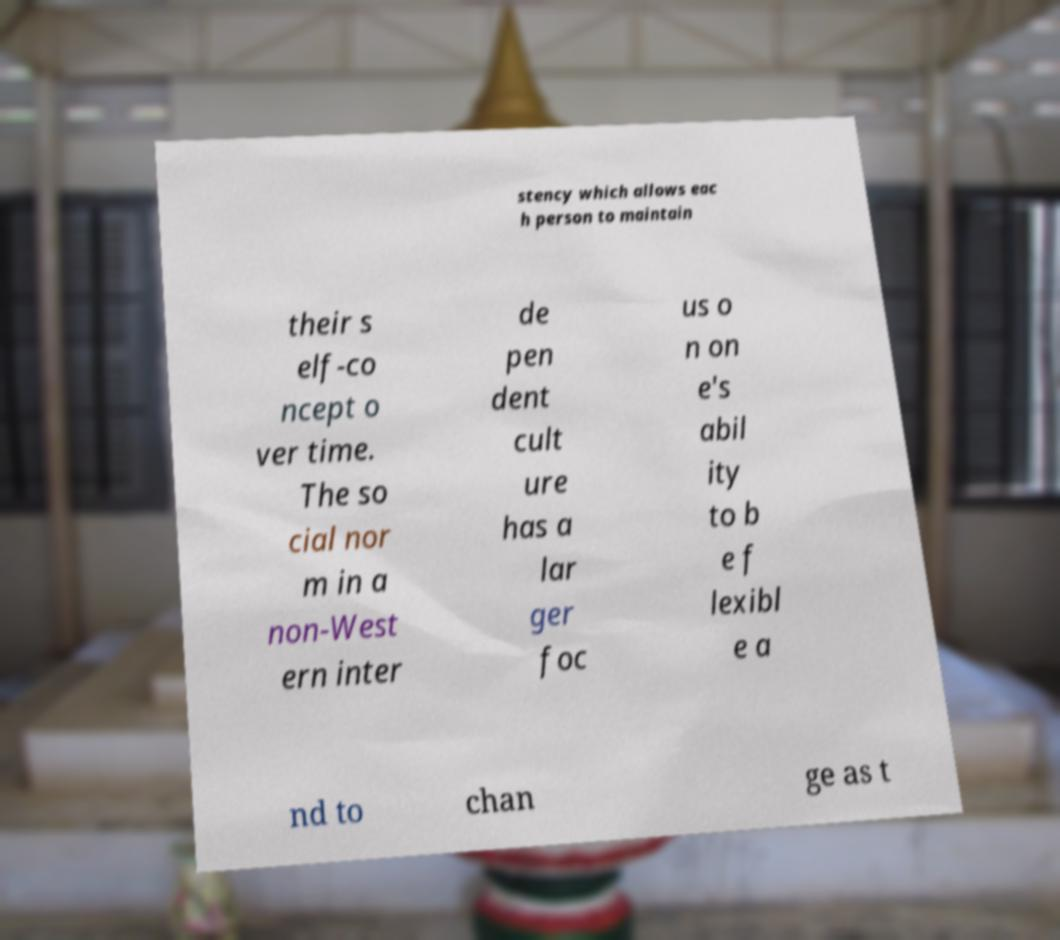Please identify and transcribe the text found in this image. stency which allows eac h person to maintain their s elf-co ncept o ver time. The so cial nor m in a non-West ern inter de pen dent cult ure has a lar ger foc us o n on e's abil ity to b e f lexibl e a nd to chan ge as t 